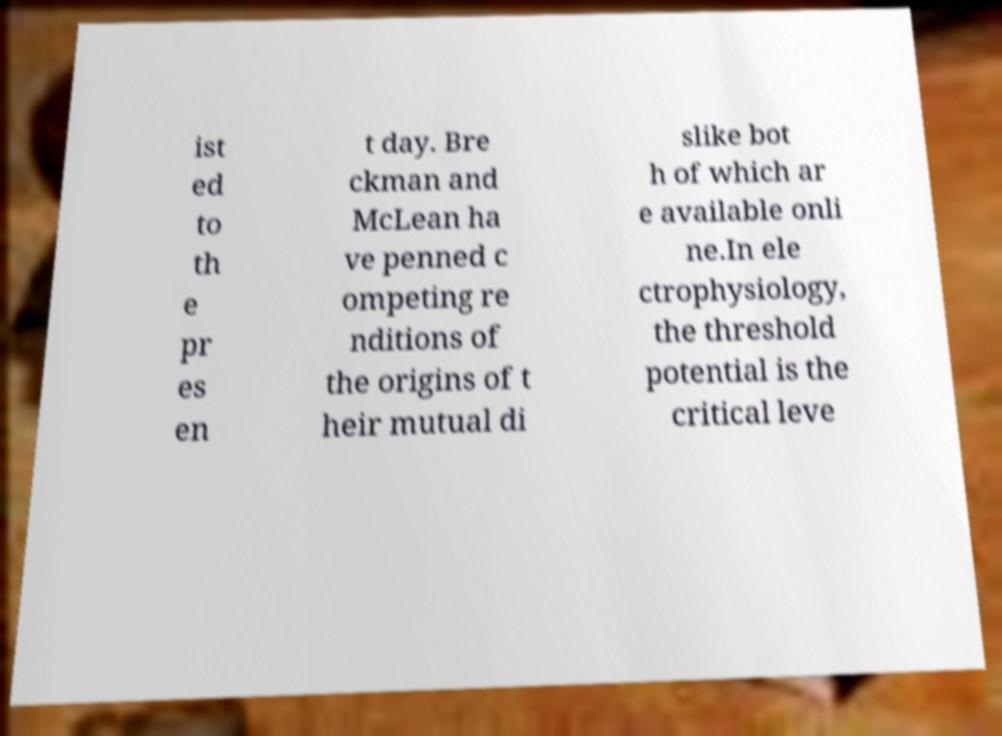Can you accurately transcribe the text from the provided image for me? ist ed to th e pr es en t day. Bre ckman and McLean ha ve penned c ompeting re nditions of the origins of t heir mutual di slike bot h of which ar e available onli ne.In ele ctrophysiology, the threshold potential is the critical leve 